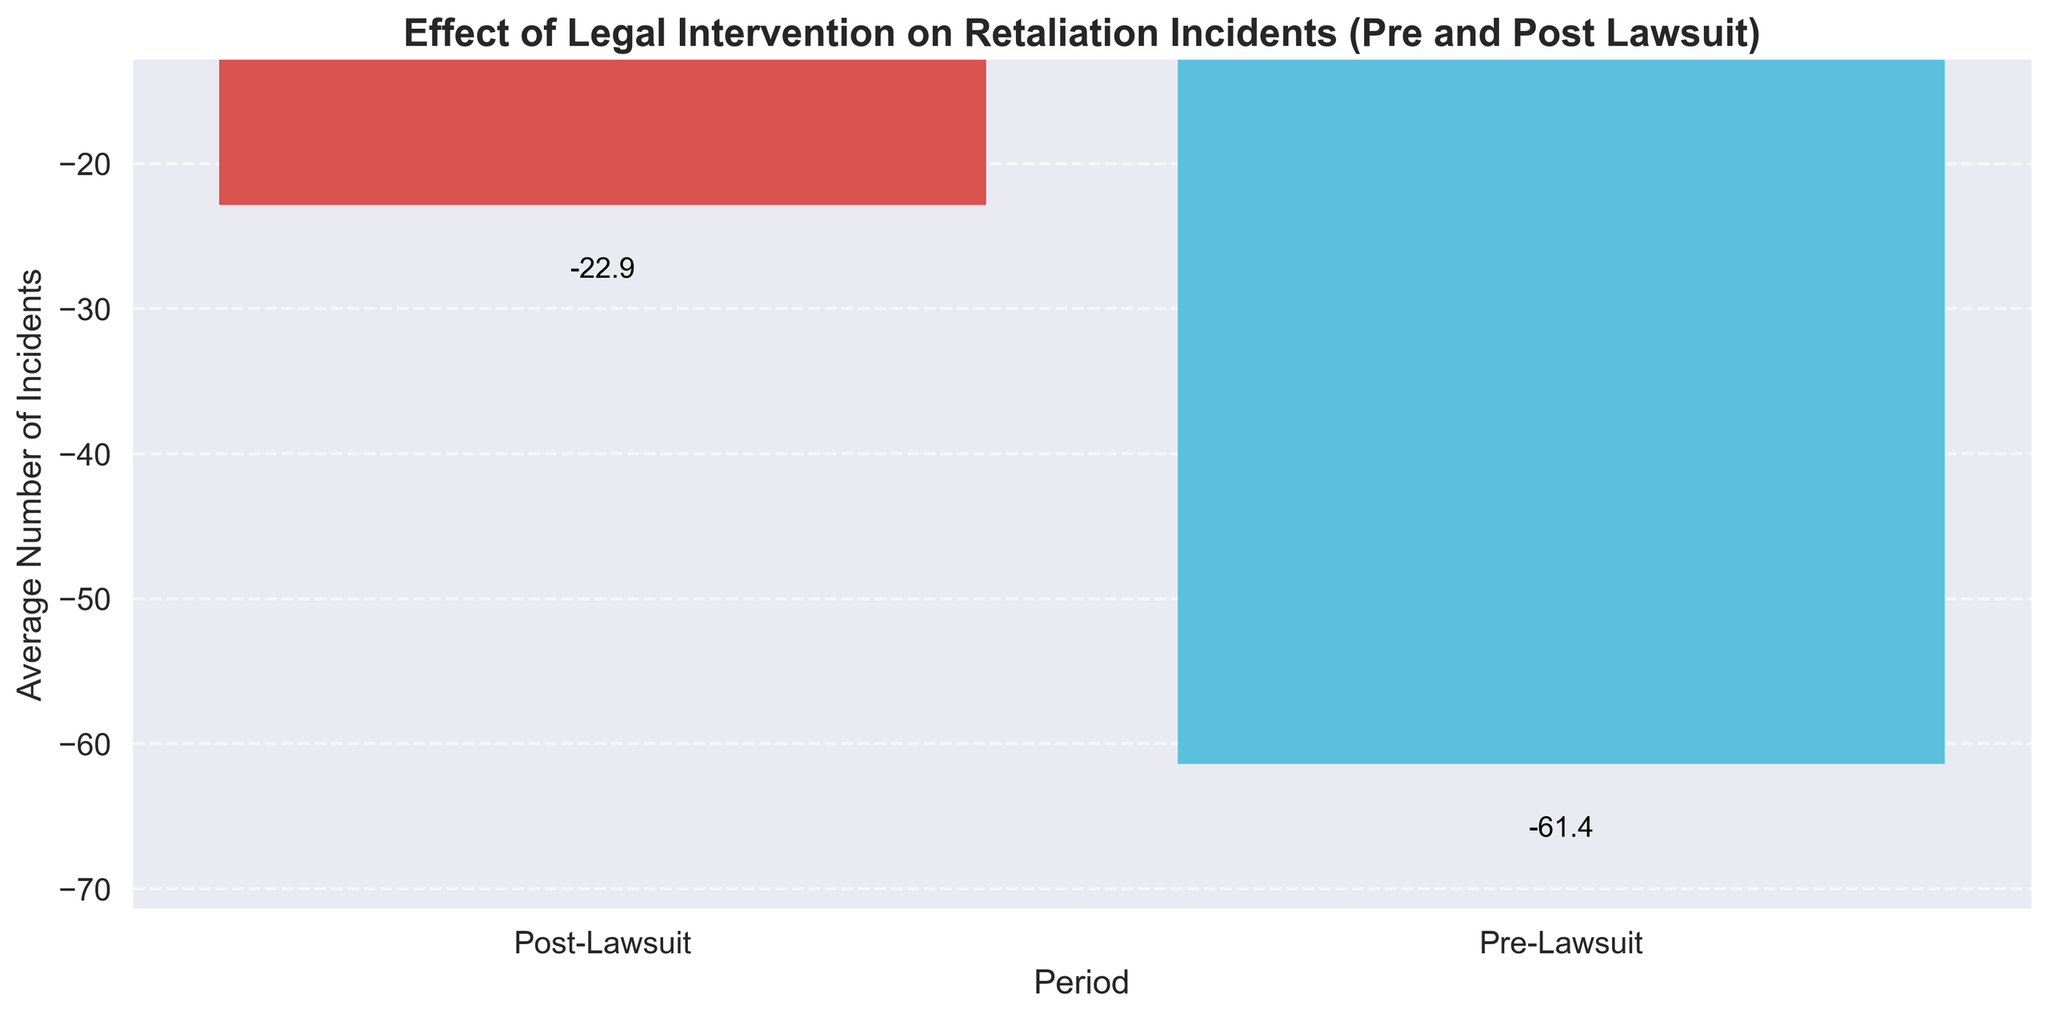What is the average number of retaliation incidents in the Pre-Lawsuit period? The data shows multiple values for the Pre-Lawsuit period. To get the average, sum the incidents and divide by the number of data points: (-55 + -60 + -70 + -65 + -58 + -62 + -54 + -73 + -61 + -57 + -64 + -56 + -59 + -60 + -67) / 15 = -61
Answer: -61 How many fewer incidents are there on average in the Post-Lawsuit period compared to the Pre-Lawsuit period? Calculate the average of Pre-Lawsuit incidents (-61). Calculate the average of Post-Lawsuit incidents: (-30 + -25 + -20 + -18 + -22 + -15 + -28 + -19 + -24 + -29 + -21 + -27 + -23 + -26 + -16) / 15 = -23. Subtract the Post-Lawsuit average from the Pre-Lawsuit average: -61 - (-23) = -38
Answer: 38 Which period has a higher average number of retaliation incidents? Compare the average incidents of the two periods calculated earlier: Pre-Lawsuit is -61 and Post-Lawsuit is -23. Since -61 is less than -23 (closer to zero), Pre-Lawsuit has more incidents.
Answer: Pre-Lawsuit What does the height of the bar in the 'Post-Lawsuit' period represent in terms of average incidents? The bar height for 'Post-Lawsuit' visually represents the average number of incidents, which is -23. This is indicated by the text label near the top of the blue bar.
Answer: -23 What is the total number of incidents in the Pre-Lawsuit period? Sum the incidents in the Pre-Lawsuit period: -55 + -60 + -70 + -65 + -58 + -62 + -54 + -73 + -61 + -57 + -64 + -56 + -59 + -60 + -67 = -921
Answer: -921 How many fewer incidents are there in the Post-Lawsuit period compared to the total Pre-Lawsuit period? Calculate the total incidents in the Post-Lawsuit period: -30 + -25 + -20 + -18 + -22 + -15 + -28 + -19 + -24 + -29 + -21 + -27 + -23 + -26 + -16 = -343. Subtract this from the total Pre-Lawsuit incidents: -921 - (-343) = -578
Answer: 578 Does the chart show more incidents before or after the lawsuit? The chart's bar heights indicate values. The 'Pre-Lawsuit' bar is taller with an average of -61 compared to -23 for 'Post-Lawsuit,' showing more incidents before the lawsuit.
Answer: Before By how much did the average number of incidents decrease after the lawsuit? The decrease is the difference between the average numbers: -61 (Pre-Lawsuit) - (-23) (Post-Lawsuit) = -38.
Answer: 38 Which period has fewer incidents on average, and by how many? Compare averages: -61 for Pre-Lawsuit vs. -23 for Post-Lawsuit. Post-Lawsuit is higher (closer to zero) by 38.
Answer: Post-Lawsuit, 38 